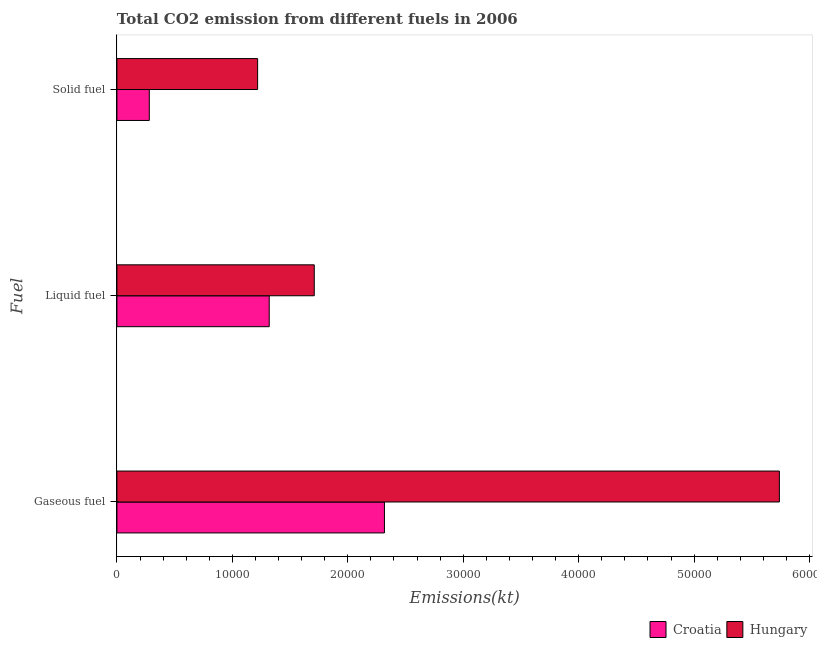How many groups of bars are there?
Provide a succinct answer. 3. Are the number of bars per tick equal to the number of legend labels?
Offer a terse response. Yes. What is the label of the 1st group of bars from the top?
Your answer should be compact. Solid fuel. What is the amount of co2 emissions from gaseous fuel in Hungary?
Offer a terse response. 5.74e+04. Across all countries, what is the maximum amount of co2 emissions from solid fuel?
Your response must be concise. 1.22e+04. Across all countries, what is the minimum amount of co2 emissions from gaseous fuel?
Offer a very short reply. 2.32e+04. In which country was the amount of co2 emissions from liquid fuel maximum?
Keep it short and to the point. Hungary. In which country was the amount of co2 emissions from liquid fuel minimum?
Make the answer very short. Croatia. What is the total amount of co2 emissions from solid fuel in the graph?
Your answer should be compact. 1.50e+04. What is the difference between the amount of co2 emissions from liquid fuel in Croatia and that in Hungary?
Give a very brief answer. -3901.69. What is the difference between the amount of co2 emissions from liquid fuel in Croatia and the amount of co2 emissions from gaseous fuel in Hungary?
Your response must be concise. -4.42e+04. What is the average amount of co2 emissions from liquid fuel per country?
Provide a succinct answer. 1.51e+04. What is the difference between the amount of co2 emissions from liquid fuel and amount of co2 emissions from solid fuel in Croatia?
Ensure brevity in your answer.  1.04e+04. What is the ratio of the amount of co2 emissions from solid fuel in Croatia to that in Hungary?
Keep it short and to the point. 0.23. Is the amount of co2 emissions from gaseous fuel in Hungary less than that in Croatia?
Your answer should be very brief. No. Is the difference between the amount of co2 emissions from solid fuel in Hungary and Croatia greater than the difference between the amount of co2 emissions from liquid fuel in Hungary and Croatia?
Provide a short and direct response. Yes. What is the difference between the highest and the second highest amount of co2 emissions from liquid fuel?
Keep it short and to the point. 3901.69. What is the difference between the highest and the lowest amount of co2 emissions from liquid fuel?
Your answer should be compact. 3901.69. In how many countries, is the amount of co2 emissions from solid fuel greater than the average amount of co2 emissions from solid fuel taken over all countries?
Make the answer very short. 1. What does the 1st bar from the top in Gaseous fuel represents?
Offer a very short reply. Hungary. What does the 2nd bar from the bottom in Solid fuel represents?
Make the answer very short. Hungary. What is the difference between two consecutive major ticks on the X-axis?
Make the answer very short. 10000. Are the values on the major ticks of X-axis written in scientific E-notation?
Keep it short and to the point. No. Where does the legend appear in the graph?
Make the answer very short. Bottom right. What is the title of the graph?
Give a very brief answer. Total CO2 emission from different fuels in 2006. Does "Russian Federation" appear as one of the legend labels in the graph?
Provide a succinct answer. No. What is the label or title of the X-axis?
Ensure brevity in your answer.  Emissions(kt). What is the label or title of the Y-axis?
Your answer should be compact. Fuel. What is the Emissions(kt) of Croatia in Gaseous fuel?
Your response must be concise. 2.32e+04. What is the Emissions(kt) of Hungary in Gaseous fuel?
Provide a succinct answer. 5.74e+04. What is the Emissions(kt) in Croatia in Liquid fuel?
Provide a short and direct response. 1.32e+04. What is the Emissions(kt) of Hungary in Liquid fuel?
Your answer should be very brief. 1.71e+04. What is the Emissions(kt) of Croatia in Solid fuel?
Your answer should be compact. 2805.26. What is the Emissions(kt) of Hungary in Solid fuel?
Provide a succinct answer. 1.22e+04. Across all Fuel, what is the maximum Emissions(kt) of Croatia?
Offer a terse response. 2.32e+04. Across all Fuel, what is the maximum Emissions(kt) of Hungary?
Your answer should be very brief. 5.74e+04. Across all Fuel, what is the minimum Emissions(kt) of Croatia?
Offer a very short reply. 2805.26. Across all Fuel, what is the minimum Emissions(kt) in Hungary?
Make the answer very short. 1.22e+04. What is the total Emissions(kt) of Croatia in the graph?
Your answer should be very brief. 3.92e+04. What is the total Emissions(kt) of Hungary in the graph?
Ensure brevity in your answer.  8.67e+04. What is the difference between the Emissions(kt) of Croatia in Gaseous fuel and that in Liquid fuel?
Make the answer very short. 9981.57. What is the difference between the Emissions(kt) in Hungary in Gaseous fuel and that in Liquid fuel?
Make the answer very short. 4.03e+04. What is the difference between the Emissions(kt) of Croatia in Gaseous fuel and that in Solid fuel?
Provide a succinct answer. 2.04e+04. What is the difference between the Emissions(kt) of Hungary in Gaseous fuel and that in Solid fuel?
Your response must be concise. 4.52e+04. What is the difference between the Emissions(kt) of Croatia in Liquid fuel and that in Solid fuel?
Give a very brief answer. 1.04e+04. What is the difference between the Emissions(kt) in Hungary in Liquid fuel and that in Solid fuel?
Offer a terse response. 4906.45. What is the difference between the Emissions(kt) of Croatia in Gaseous fuel and the Emissions(kt) of Hungary in Liquid fuel?
Keep it short and to the point. 6079.89. What is the difference between the Emissions(kt) of Croatia in Gaseous fuel and the Emissions(kt) of Hungary in Solid fuel?
Provide a short and direct response. 1.10e+04. What is the difference between the Emissions(kt) in Croatia in Liquid fuel and the Emissions(kt) in Hungary in Solid fuel?
Offer a terse response. 1004.76. What is the average Emissions(kt) of Croatia per Fuel?
Your answer should be very brief. 1.31e+04. What is the average Emissions(kt) in Hungary per Fuel?
Your answer should be compact. 2.89e+04. What is the difference between the Emissions(kt) of Croatia and Emissions(kt) of Hungary in Gaseous fuel?
Give a very brief answer. -3.42e+04. What is the difference between the Emissions(kt) in Croatia and Emissions(kt) in Hungary in Liquid fuel?
Offer a terse response. -3901.69. What is the difference between the Emissions(kt) in Croatia and Emissions(kt) in Hungary in Solid fuel?
Your response must be concise. -9383.85. What is the ratio of the Emissions(kt) in Croatia in Gaseous fuel to that in Liquid fuel?
Ensure brevity in your answer.  1.76. What is the ratio of the Emissions(kt) in Hungary in Gaseous fuel to that in Liquid fuel?
Make the answer very short. 3.36. What is the ratio of the Emissions(kt) in Croatia in Gaseous fuel to that in Solid fuel?
Offer a terse response. 8.26. What is the ratio of the Emissions(kt) of Hungary in Gaseous fuel to that in Solid fuel?
Provide a short and direct response. 4.71. What is the ratio of the Emissions(kt) of Croatia in Liquid fuel to that in Solid fuel?
Keep it short and to the point. 4.7. What is the ratio of the Emissions(kt) in Hungary in Liquid fuel to that in Solid fuel?
Ensure brevity in your answer.  1.4. What is the difference between the highest and the second highest Emissions(kt) of Croatia?
Offer a very short reply. 9981.57. What is the difference between the highest and the second highest Emissions(kt) of Hungary?
Provide a succinct answer. 4.03e+04. What is the difference between the highest and the lowest Emissions(kt) of Croatia?
Offer a terse response. 2.04e+04. What is the difference between the highest and the lowest Emissions(kt) of Hungary?
Make the answer very short. 4.52e+04. 